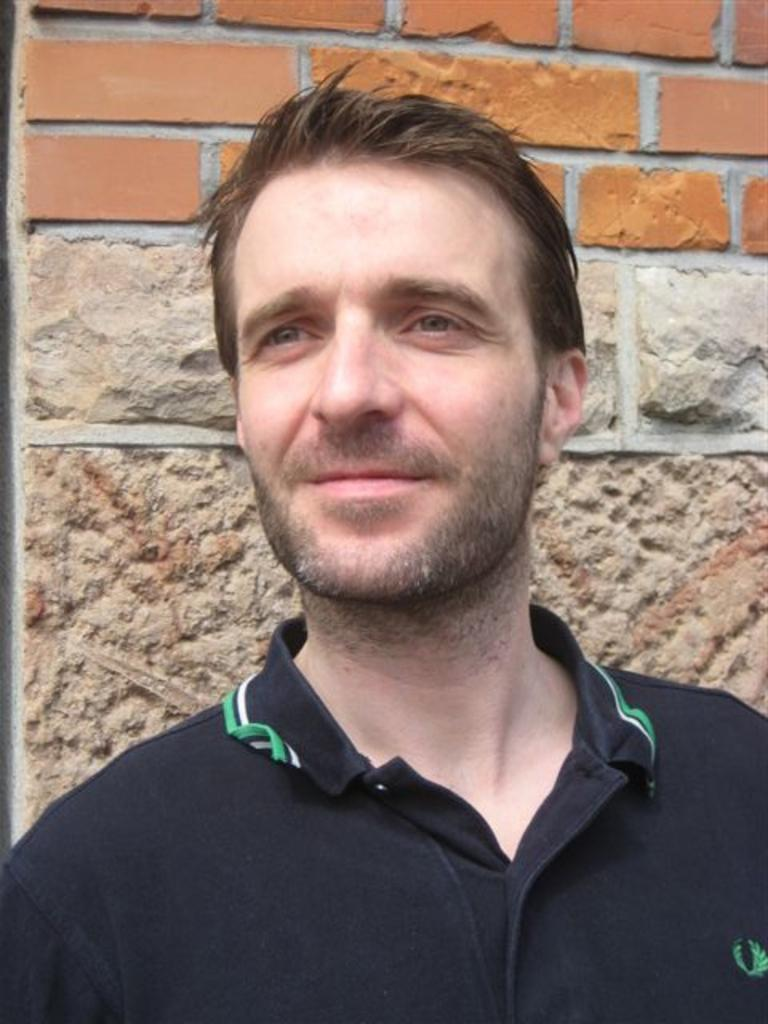Who is present in the image? There is a man in the image. What is the man wearing? The man is wearing a black t-shirt. What is the man's facial expression? The man is smiling. In which direction is the man looking? The man is looking to the left side. What can be seen in the background of the image? There is a wall in the background of the image. Is the man in the image holding a camera? There is no camera visible in the image, and the man is not holding one. 